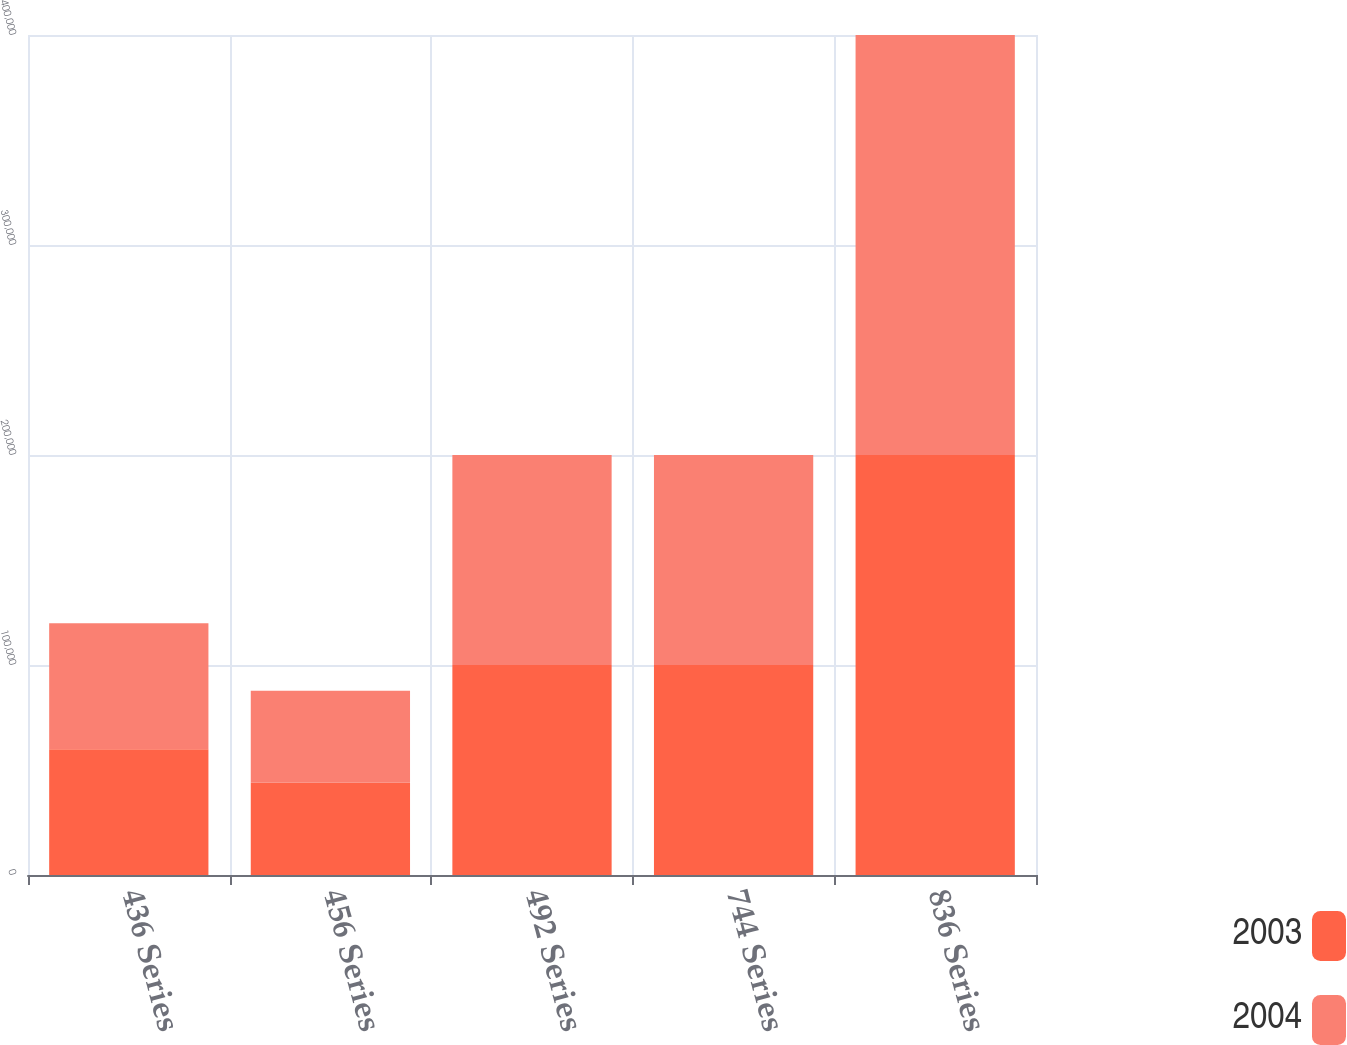<chart> <loc_0><loc_0><loc_500><loc_500><stacked_bar_chart><ecel><fcel>436 Series<fcel>456 Series<fcel>492 Series<fcel>744 Series<fcel>836 Series<nl><fcel>2003<fcel>59920<fcel>43887<fcel>100000<fcel>100000<fcel>200000<nl><fcel>2004<fcel>59920<fcel>43887<fcel>100000<fcel>100000<fcel>200000<nl></chart> 